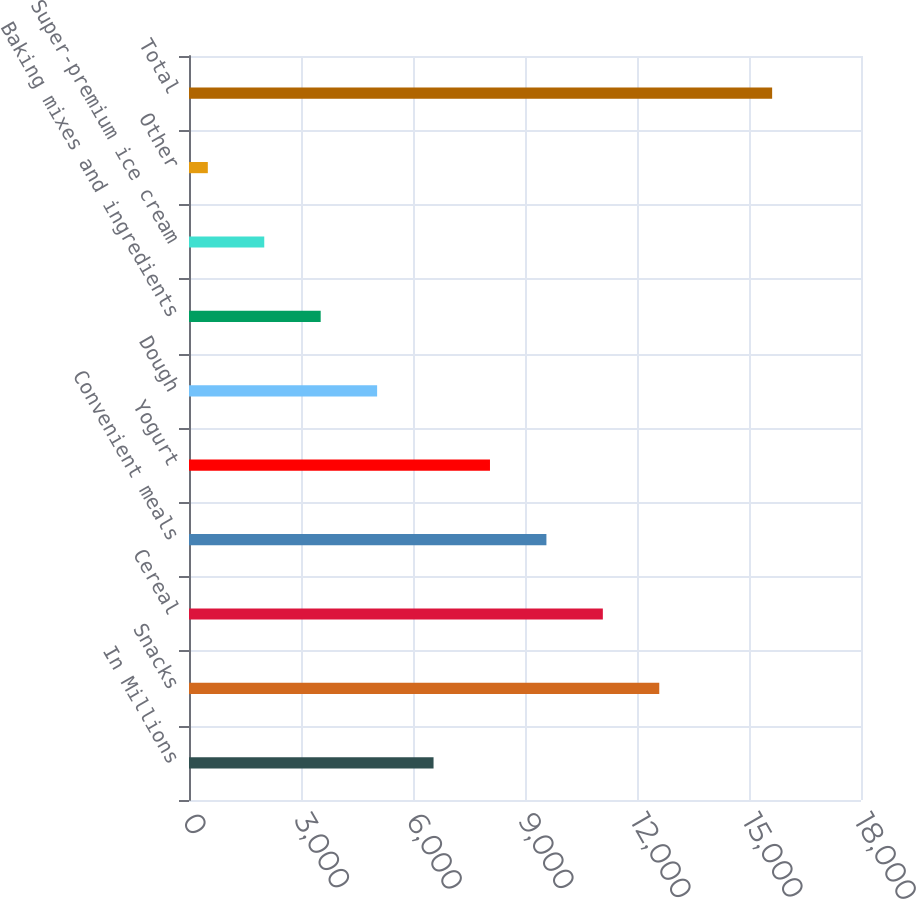Convert chart. <chart><loc_0><loc_0><loc_500><loc_500><bar_chart><fcel>In Millions<fcel>Snacks<fcel>Cereal<fcel>Convenient meals<fcel>Yogurt<fcel>Dough<fcel>Baking mixes and ingredients<fcel>Super-premium ice cream<fcel>Other<fcel>Total<nl><fcel>6550.44<fcel>12596.7<fcel>11085.1<fcel>9573.56<fcel>8062<fcel>5038.88<fcel>3527.32<fcel>2015.76<fcel>504.2<fcel>15619.8<nl></chart> 